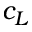<formula> <loc_0><loc_0><loc_500><loc_500>c _ { L }</formula> 